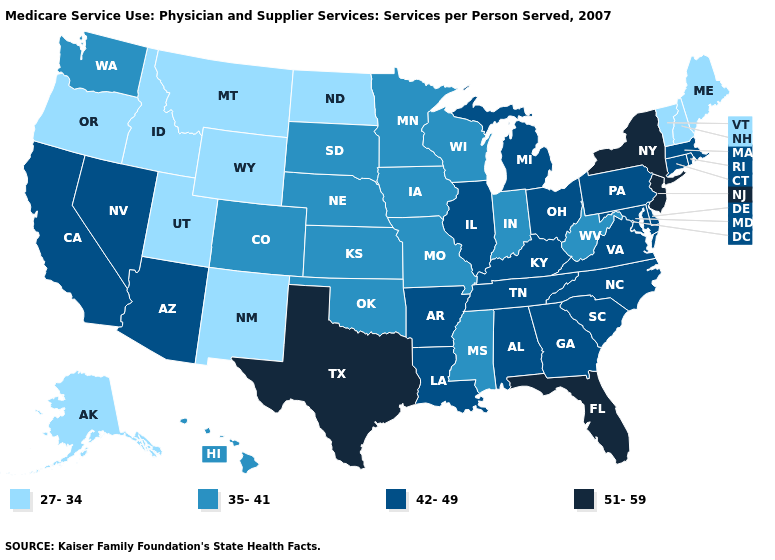Does New York have the highest value in the USA?
Be succinct. Yes. How many symbols are there in the legend?
Keep it brief. 4. What is the highest value in the West ?
Write a very short answer. 42-49. Does North Dakota have the lowest value in the MidWest?
Write a very short answer. Yes. Does Ohio have a higher value than Colorado?
Keep it brief. Yes. Does Maine have the lowest value in the USA?
Short answer required. Yes. Is the legend a continuous bar?
Concise answer only. No. What is the highest value in states that border Arizona?
Quick response, please. 42-49. Name the states that have a value in the range 51-59?
Concise answer only. Florida, New Jersey, New York, Texas. Does Connecticut have the lowest value in the Northeast?
Answer briefly. No. What is the value of Nebraska?
Keep it brief. 35-41. Name the states that have a value in the range 35-41?
Answer briefly. Colorado, Hawaii, Indiana, Iowa, Kansas, Minnesota, Mississippi, Missouri, Nebraska, Oklahoma, South Dakota, Washington, West Virginia, Wisconsin. Among the states that border New Hampshire , which have the lowest value?
Quick response, please. Maine, Vermont. Name the states that have a value in the range 27-34?
Concise answer only. Alaska, Idaho, Maine, Montana, New Hampshire, New Mexico, North Dakota, Oregon, Utah, Vermont, Wyoming. 